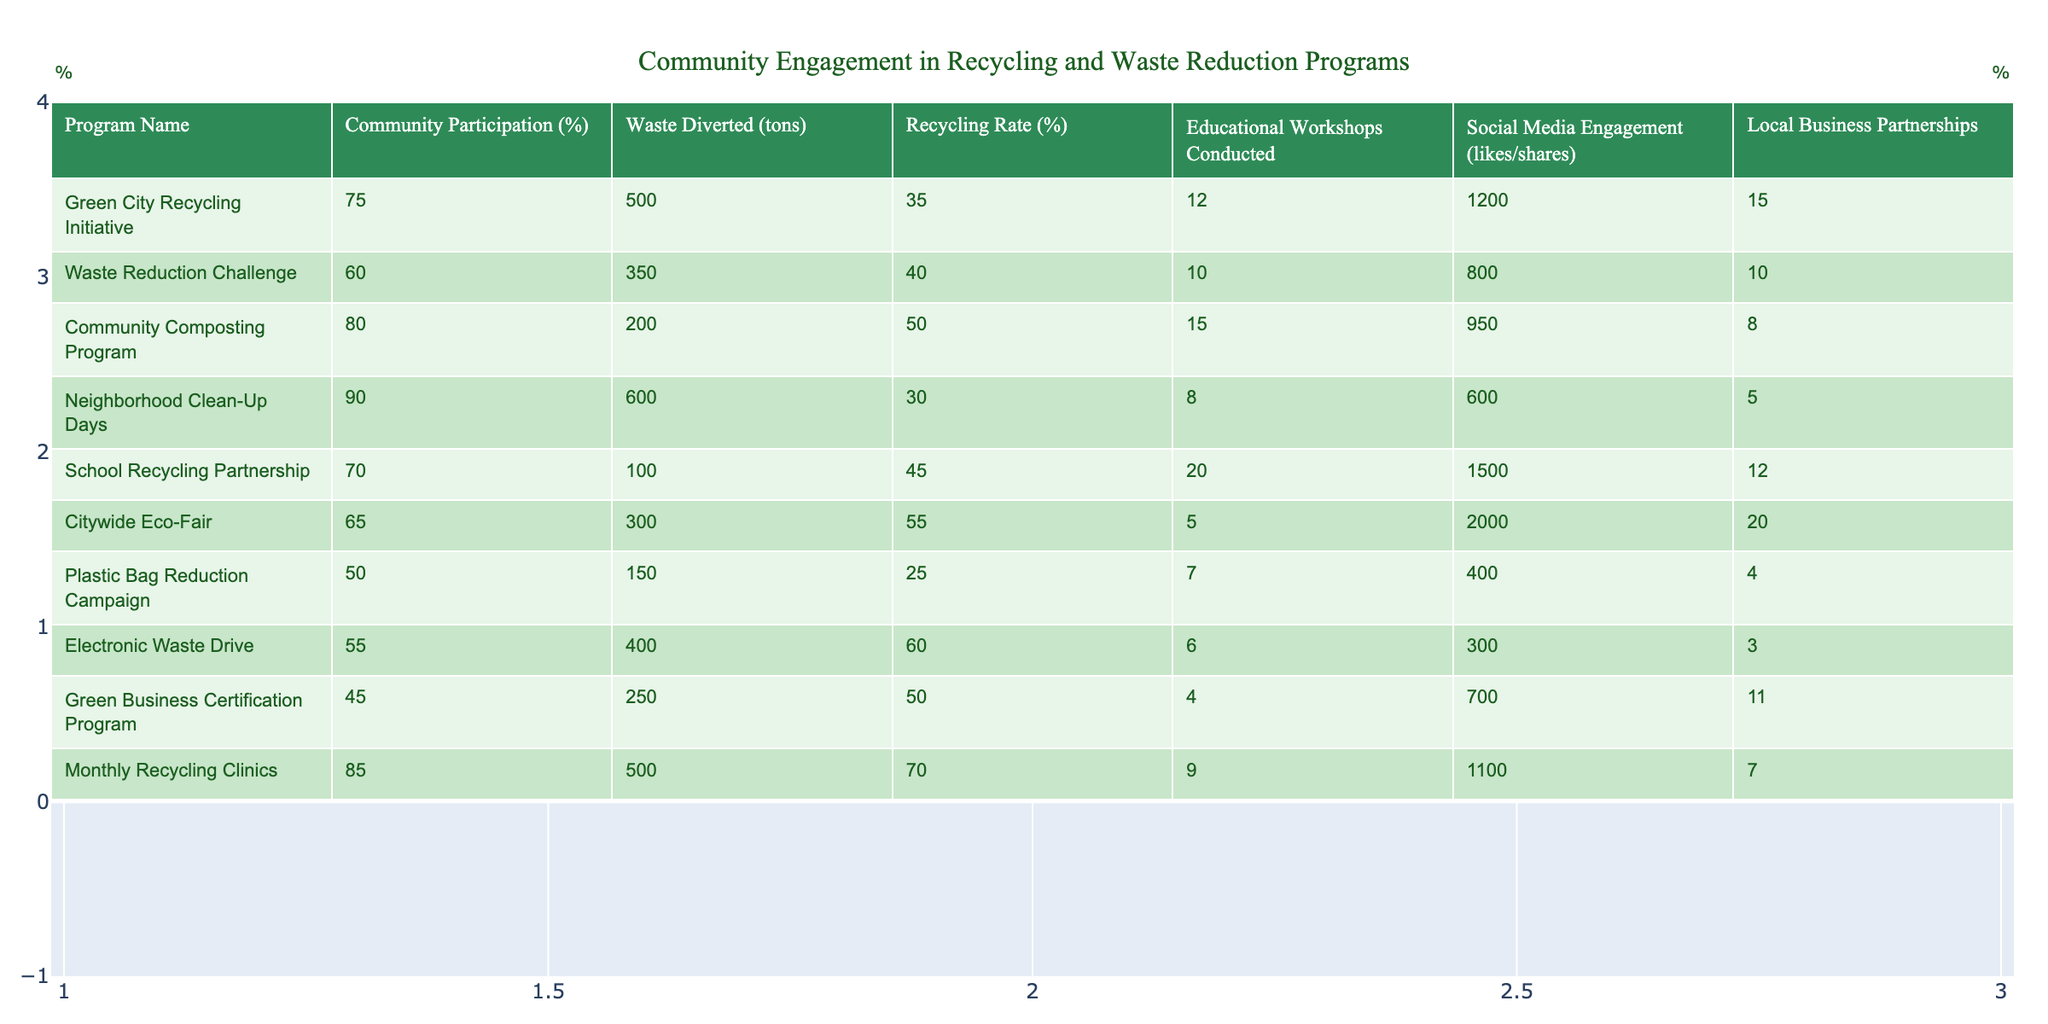What program had the highest community participation percentage? The highest community participation percentage is found in the "Neighborhood Clean-Up Days" program, which had 90% participation.
Answer: 90% Which program diverted the least amount of waste? The program that diverted the least amount of waste is the "Green Business Certification Program," with only 250 tons diverted.
Answer: 250 tons What is the average recycling rate across all programs? The recycling rates are 35, 40, 50, 30, 45, 55, 25, 60, 50, and 70. Summing these gives 460, and there are 10 programs, resulting in an average recycling rate of 460/10 = 46%.
Answer: 46% Which program had the highest educational workshops conducted? The "School Recycling Partnership" program held the highest number of educational workshops, with a total of 20.
Answer: 20 Is the "Plastic Bag Reduction Campaign" more effective in waste diversion than the "Waste Reduction Challenge"? The "Plastic Bag Reduction Campaign" diverted 150 tons of waste, while the "Waste Reduction Challenge" diverted 350 tons, making the Waste Reduction Challenge more effective.
Answer: No What is the total waste diverted by the "Community Composting Program" and "Citywide Eco-Fair"? The "Community Composting Program" diverted 200 tons and the "Citywide Eco-Fair" diverted 300 tons. Adding these gives 200 + 300 = 500 tons diverted in total.
Answer: 500 tons How many local business partnerships were formed in total across all programs? The total number of local business partnerships is found by summing the partnerships: 15 + 10 + 8 + 5 + 12 + 20 + 4 + 3 + 11 + 7 = 95.
Answer: 95 Which program had the highest social media engagement? The program with the highest social media engagement is the "Citywide Eco-Fair," with 2000 likes and shares.
Answer: 2000 Are educational workshops correlated with higher community participation? Looking at the table, higher community participation percentages do not consistently correlate with the number of educational workshops conducted. For example, "Neighborhood Clean-Up Days" has high participation but fewer workshops.
Answer: No What is the difference in waste diverted between the "Electronic Waste Drive" and the "Green City Recycling Initiative"? The "Electronic Waste Drive" diverted 400 tons and the "Green City Recycling Initiative" diverted 500 tons. The difference is 500 - 400 = 100 tons.
Answer: 100 tons 